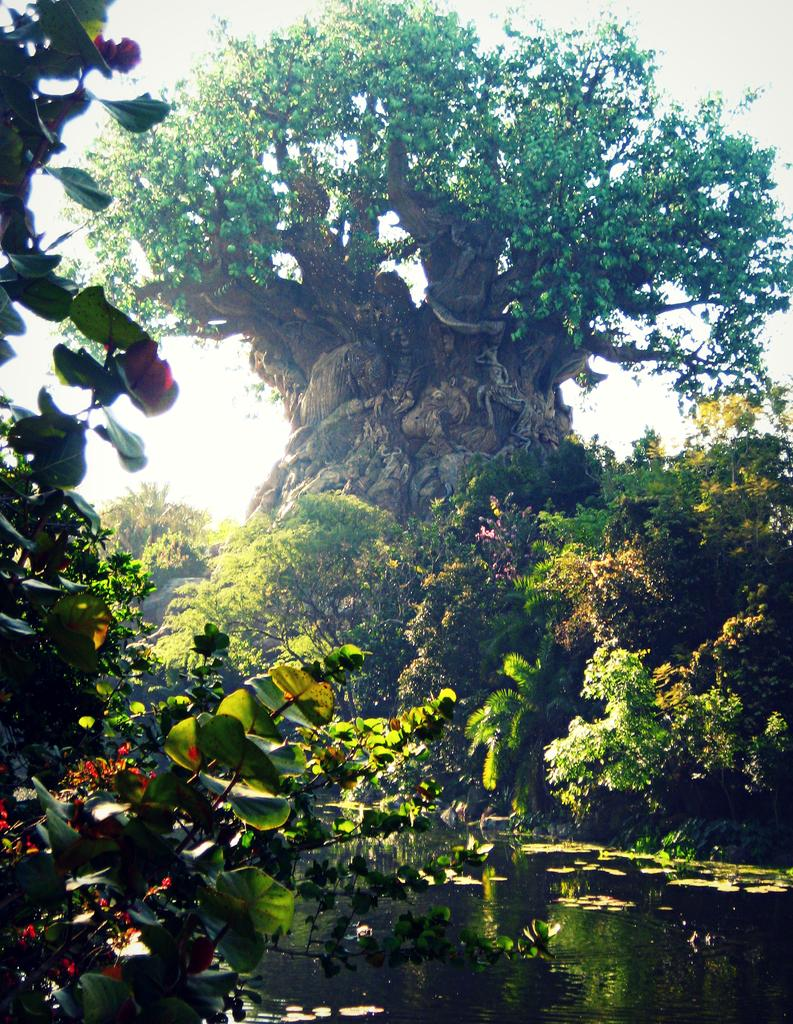What type of natural elements are present in the image? There is a group of trees and plants in the image. What can be seen at the bottom of the image? There is water visible at the bottom of the image. Are there any leaves in the water? Yes, there are leaves in the water. What is visible at the top of the image? The sky is visible at the top of the image. What songs are being sung by the campers near the bridge in the image? There are no campers or bridge present in the image; it features a group of trees, plants, water, and leaves. 